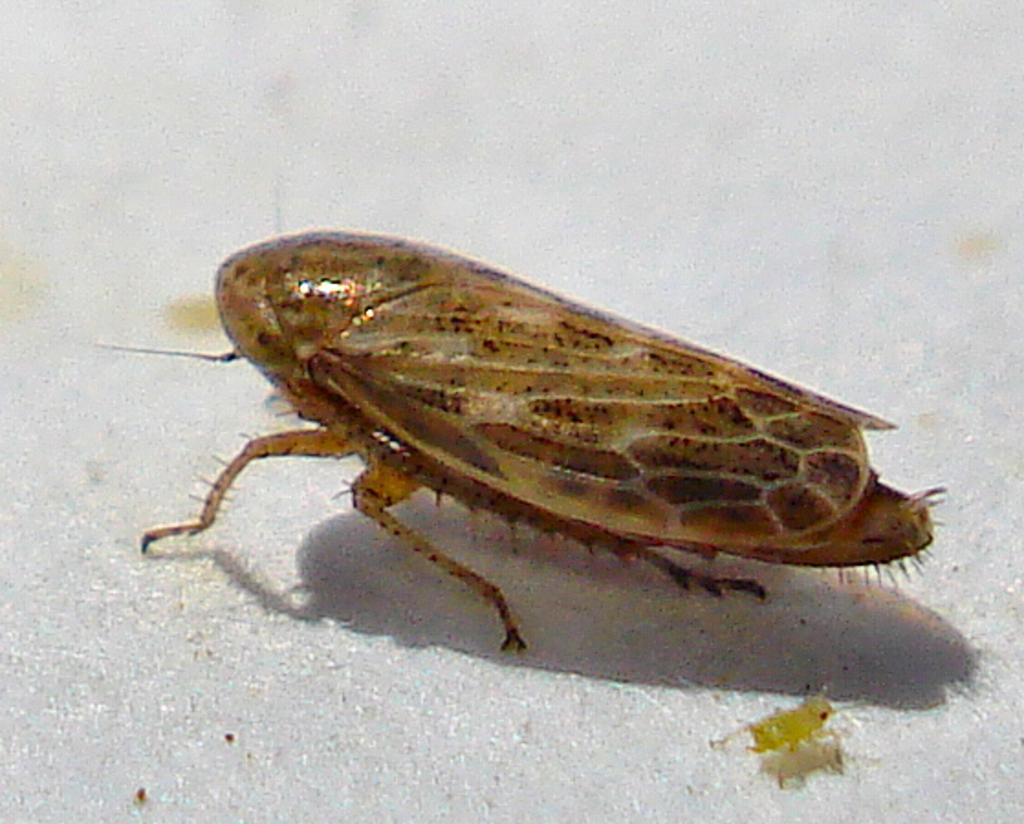What type of insects can be seen in the image? There is a brown insect and a small yellow insect in the image. Can you describe the appearance of the brown insect? The brown insect is visible in the image, but no specific details about its appearance are provided. How many insects are present in the image? There are two insects in the image, a brown one and a small yellow one. What type of truck can be seen driving through the image? There is no truck present in the image; it only features two insects. Can you tell me how many words are written on the insects in the image? There is no text or words present on the insects in the image. 